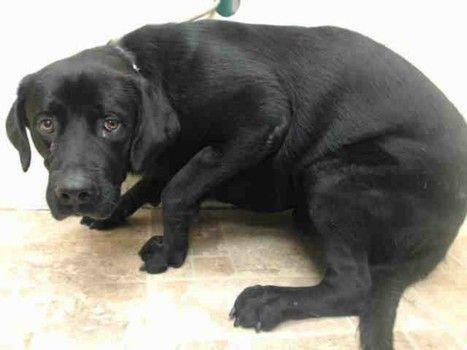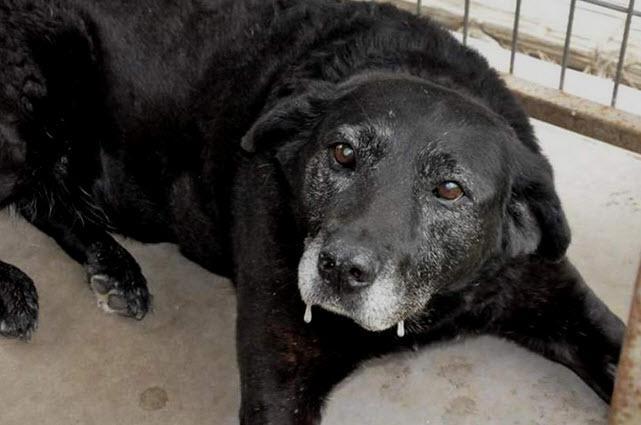The first image is the image on the left, the second image is the image on the right. Given the left and right images, does the statement "An image featuring reclining labrador retrievers includes one """"blond"""" dog." hold true? Answer yes or no. No. The first image is the image on the left, the second image is the image on the right. Assess this claim about the two images: "The left image contains no more than one dog.". Correct or not? Answer yes or no. Yes. 